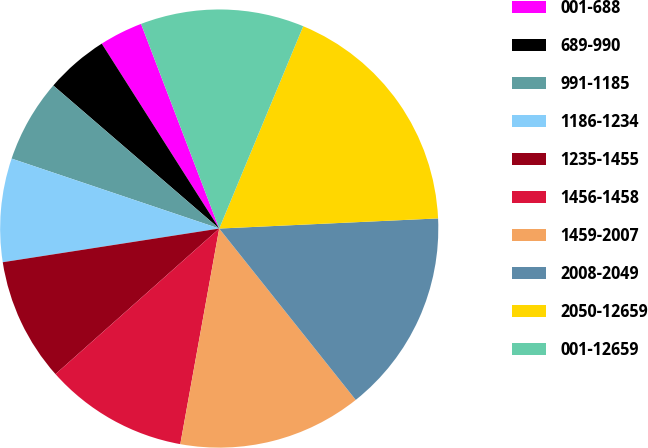<chart> <loc_0><loc_0><loc_500><loc_500><pie_chart><fcel>001-688<fcel>689-990<fcel>991-1185<fcel>1186-1234<fcel>1235-1455<fcel>1456-1458<fcel>1459-2007<fcel>2008-2049<fcel>2050-12659<fcel>001-12659<nl><fcel>3.2%<fcel>4.67%<fcel>6.15%<fcel>7.63%<fcel>9.11%<fcel>10.59%<fcel>13.55%<fcel>15.03%<fcel>18.0%<fcel>12.07%<nl></chart> 